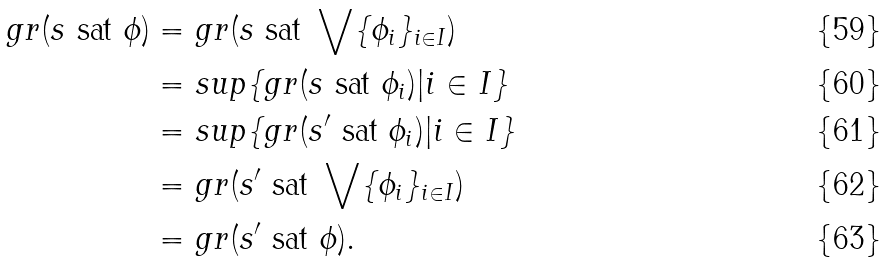<formula> <loc_0><loc_0><loc_500><loc_500>g r ( s \ \text {sat} \ \phi ) & = g r ( s \ \text {sat} \ \bigvee \{ \phi _ { i } \} _ { i \in I } ) \\ & = s u p \{ g r ( s \ \text {sat} \ \phi _ { i } ) | i \in I \} \\ & = s u p \{ g r ( s ^ { \prime } \ \text {sat} \ \phi _ { i } ) | i \in I \} \\ & = g r ( s ^ { \prime } \ \text {sat} \ \bigvee \{ \phi _ { i } \} _ { i \in I } ) \\ & = g r ( s ^ { \prime } \ \text {sat} \ \phi ) .</formula> 